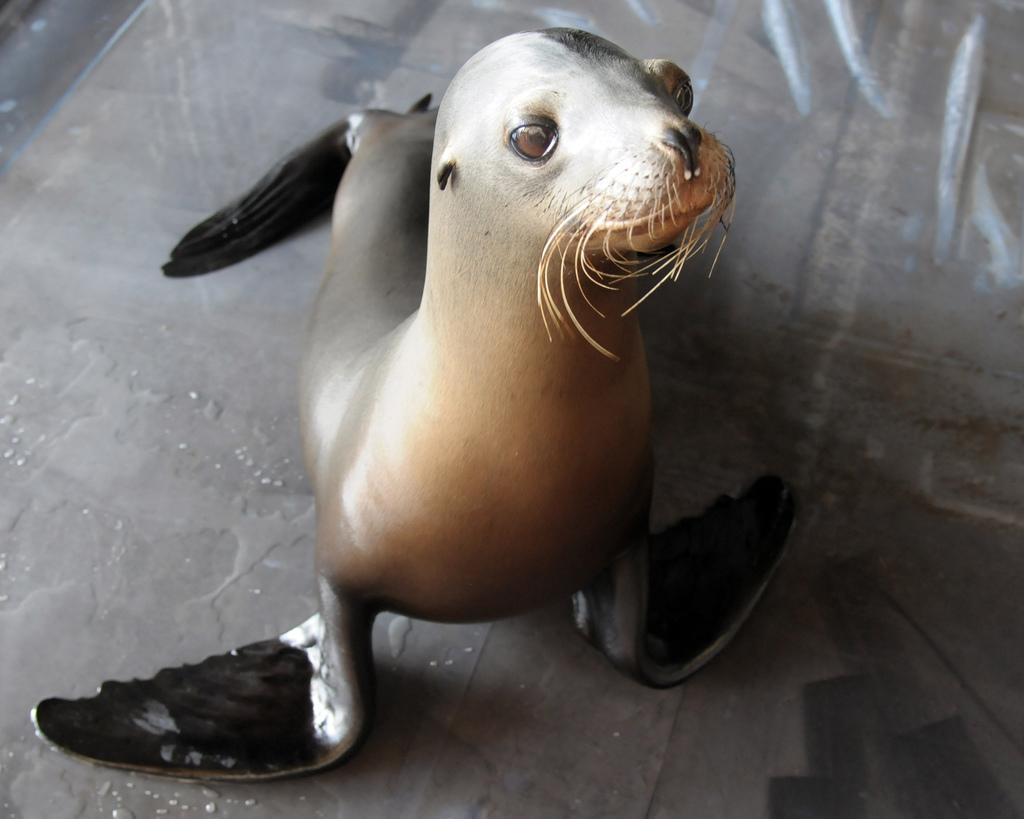What type of animal is in the image? There is a sea lion in the image. What program is the sea lion a part of? The sea lion is part of the Navy Marine Mammal Program. Where is the sea lion located in the image? The sea lion is on the floor. What color combination can be seen on the sea lion? The sea lion has a brown and black color combination. What is the weight of the ocean in the image? The image does not contain an ocean, so it is not possible to determine its weight. 